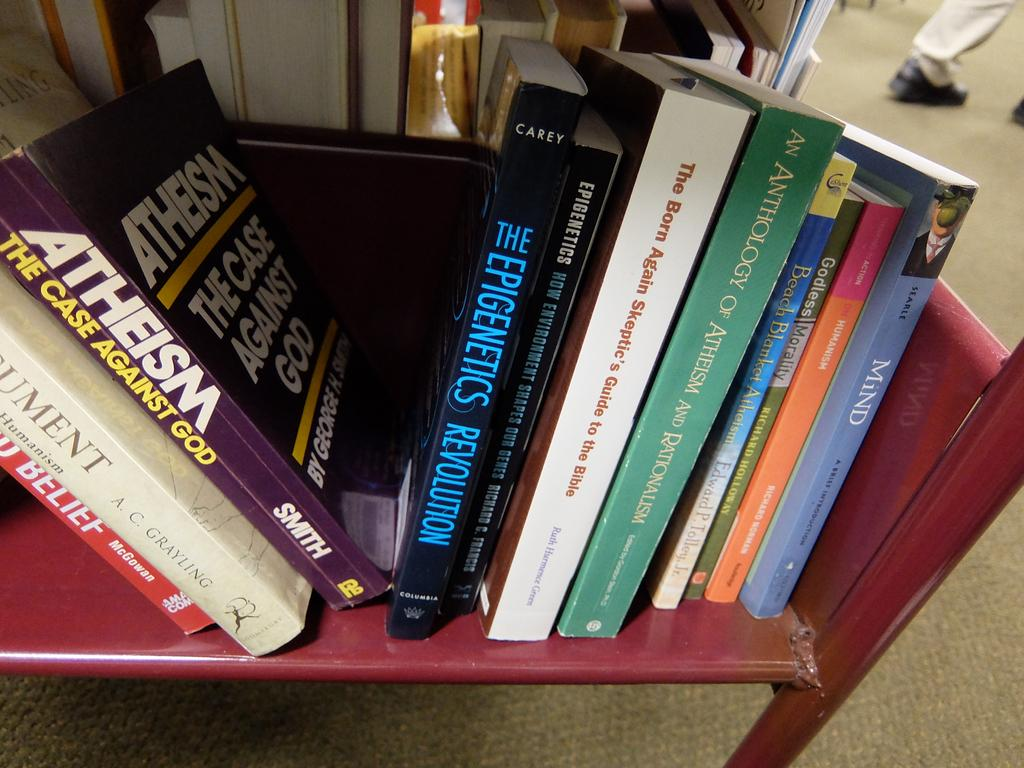<image>
Create a compact narrative representing the image presented. A number of books on a cart, one book is titled, Atheism, the case against God.. 